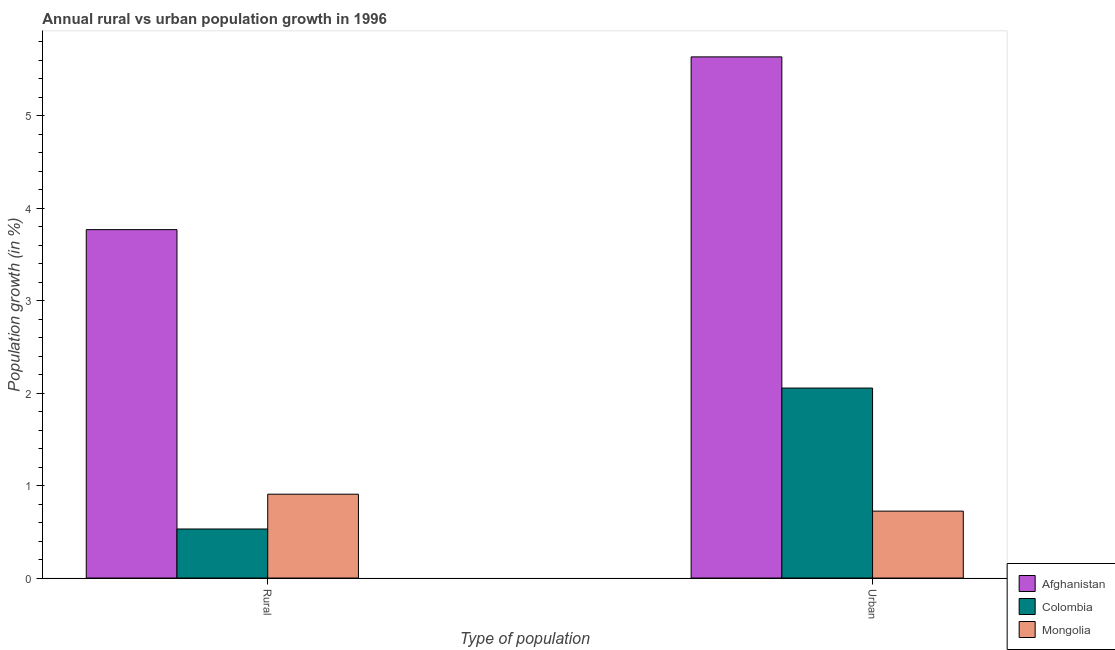How many different coloured bars are there?
Your response must be concise. 3. Are the number of bars per tick equal to the number of legend labels?
Your answer should be very brief. Yes. How many bars are there on the 2nd tick from the left?
Provide a succinct answer. 3. What is the label of the 1st group of bars from the left?
Keep it short and to the point. Rural. What is the urban population growth in Colombia?
Make the answer very short. 2.06. Across all countries, what is the maximum rural population growth?
Your answer should be compact. 3.77. Across all countries, what is the minimum rural population growth?
Offer a terse response. 0.53. In which country was the rural population growth maximum?
Your answer should be compact. Afghanistan. In which country was the urban population growth minimum?
Give a very brief answer. Mongolia. What is the total rural population growth in the graph?
Provide a short and direct response. 5.21. What is the difference between the rural population growth in Mongolia and that in Colombia?
Offer a terse response. 0.38. What is the difference between the urban population growth in Mongolia and the rural population growth in Afghanistan?
Ensure brevity in your answer.  -3.05. What is the average urban population growth per country?
Your answer should be compact. 2.81. What is the difference between the urban population growth and rural population growth in Colombia?
Offer a terse response. 1.52. In how many countries, is the rural population growth greater than 1.6 %?
Keep it short and to the point. 1. What is the ratio of the rural population growth in Colombia to that in Mongolia?
Make the answer very short. 0.59. In how many countries, is the rural population growth greater than the average rural population growth taken over all countries?
Ensure brevity in your answer.  1. What does the 1st bar from the left in Urban  represents?
Your response must be concise. Afghanistan. What does the 3rd bar from the right in Rural represents?
Provide a succinct answer. Afghanistan. Are the values on the major ticks of Y-axis written in scientific E-notation?
Make the answer very short. No. How are the legend labels stacked?
Your response must be concise. Vertical. What is the title of the graph?
Give a very brief answer. Annual rural vs urban population growth in 1996. Does "Venezuela" appear as one of the legend labels in the graph?
Offer a very short reply. No. What is the label or title of the X-axis?
Your answer should be compact. Type of population. What is the label or title of the Y-axis?
Your answer should be very brief. Population growth (in %). What is the Population growth (in %) of Afghanistan in Rural?
Your response must be concise. 3.77. What is the Population growth (in %) of Colombia in Rural?
Offer a very short reply. 0.53. What is the Population growth (in %) of Mongolia in Rural?
Offer a terse response. 0.91. What is the Population growth (in %) in Afghanistan in Urban ?
Keep it short and to the point. 5.64. What is the Population growth (in %) of Colombia in Urban ?
Ensure brevity in your answer.  2.06. What is the Population growth (in %) in Mongolia in Urban ?
Make the answer very short. 0.72. Across all Type of population, what is the maximum Population growth (in %) in Afghanistan?
Give a very brief answer. 5.64. Across all Type of population, what is the maximum Population growth (in %) of Colombia?
Provide a succinct answer. 2.06. Across all Type of population, what is the maximum Population growth (in %) of Mongolia?
Offer a very short reply. 0.91. Across all Type of population, what is the minimum Population growth (in %) in Afghanistan?
Keep it short and to the point. 3.77. Across all Type of population, what is the minimum Population growth (in %) of Colombia?
Your response must be concise. 0.53. Across all Type of population, what is the minimum Population growth (in %) of Mongolia?
Your response must be concise. 0.72. What is the total Population growth (in %) of Afghanistan in the graph?
Your answer should be compact. 9.41. What is the total Population growth (in %) in Colombia in the graph?
Your answer should be compact. 2.59. What is the total Population growth (in %) in Mongolia in the graph?
Your response must be concise. 1.63. What is the difference between the Population growth (in %) in Afghanistan in Rural and that in Urban ?
Provide a short and direct response. -1.87. What is the difference between the Population growth (in %) of Colombia in Rural and that in Urban ?
Keep it short and to the point. -1.52. What is the difference between the Population growth (in %) of Mongolia in Rural and that in Urban ?
Your response must be concise. 0.18. What is the difference between the Population growth (in %) of Afghanistan in Rural and the Population growth (in %) of Colombia in Urban?
Your response must be concise. 1.71. What is the difference between the Population growth (in %) of Afghanistan in Rural and the Population growth (in %) of Mongolia in Urban?
Your answer should be very brief. 3.05. What is the difference between the Population growth (in %) of Colombia in Rural and the Population growth (in %) of Mongolia in Urban?
Ensure brevity in your answer.  -0.19. What is the average Population growth (in %) in Afghanistan per Type of population?
Offer a terse response. 4.7. What is the average Population growth (in %) in Colombia per Type of population?
Your answer should be compact. 1.29. What is the average Population growth (in %) in Mongolia per Type of population?
Offer a very short reply. 0.82. What is the difference between the Population growth (in %) of Afghanistan and Population growth (in %) of Colombia in Rural?
Make the answer very short. 3.24. What is the difference between the Population growth (in %) in Afghanistan and Population growth (in %) in Mongolia in Rural?
Your answer should be very brief. 2.86. What is the difference between the Population growth (in %) in Colombia and Population growth (in %) in Mongolia in Rural?
Provide a short and direct response. -0.38. What is the difference between the Population growth (in %) in Afghanistan and Population growth (in %) in Colombia in Urban ?
Offer a very short reply. 3.58. What is the difference between the Population growth (in %) of Afghanistan and Population growth (in %) of Mongolia in Urban ?
Keep it short and to the point. 4.91. What is the difference between the Population growth (in %) of Colombia and Population growth (in %) of Mongolia in Urban ?
Make the answer very short. 1.33. What is the ratio of the Population growth (in %) in Afghanistan in Rural to that in Urban ?
Provide a short and direct response. 0.67. What is the ratio of the Population growth (in %) in Colombia in Rural to that in Urban ?
Provide a short and direct response. 0.26. What is the ratio of the Population growth (in %) in Mongolia in Rural to that in Urban ?
Give a very brief answer. 1.25. What is the difference between the highest and the second highest Population growth (in %) of Afghanistan?
Keep it short and to the point. 1.87. What is the difference between the highest and the second highest Population growth (in %) in Colombia?
Provide a short and direct response. 1.52. What is the difference between the highest and the second highest Population growth (in %) of Mongolia?
Provide a succinct answer. 0.18. What is the difference between the highest and the lowest Population growth (in %) of Afghanistan?
Offer a very short reply. 1.87. What is the difference between the highest and the lowest Population growth (in %) in Colombia?
Offer a terse response. 1.52. What is the difference between the highest and the lowest Population growth (in %) in Mongolia?
Your response must be concise. 0.18. 